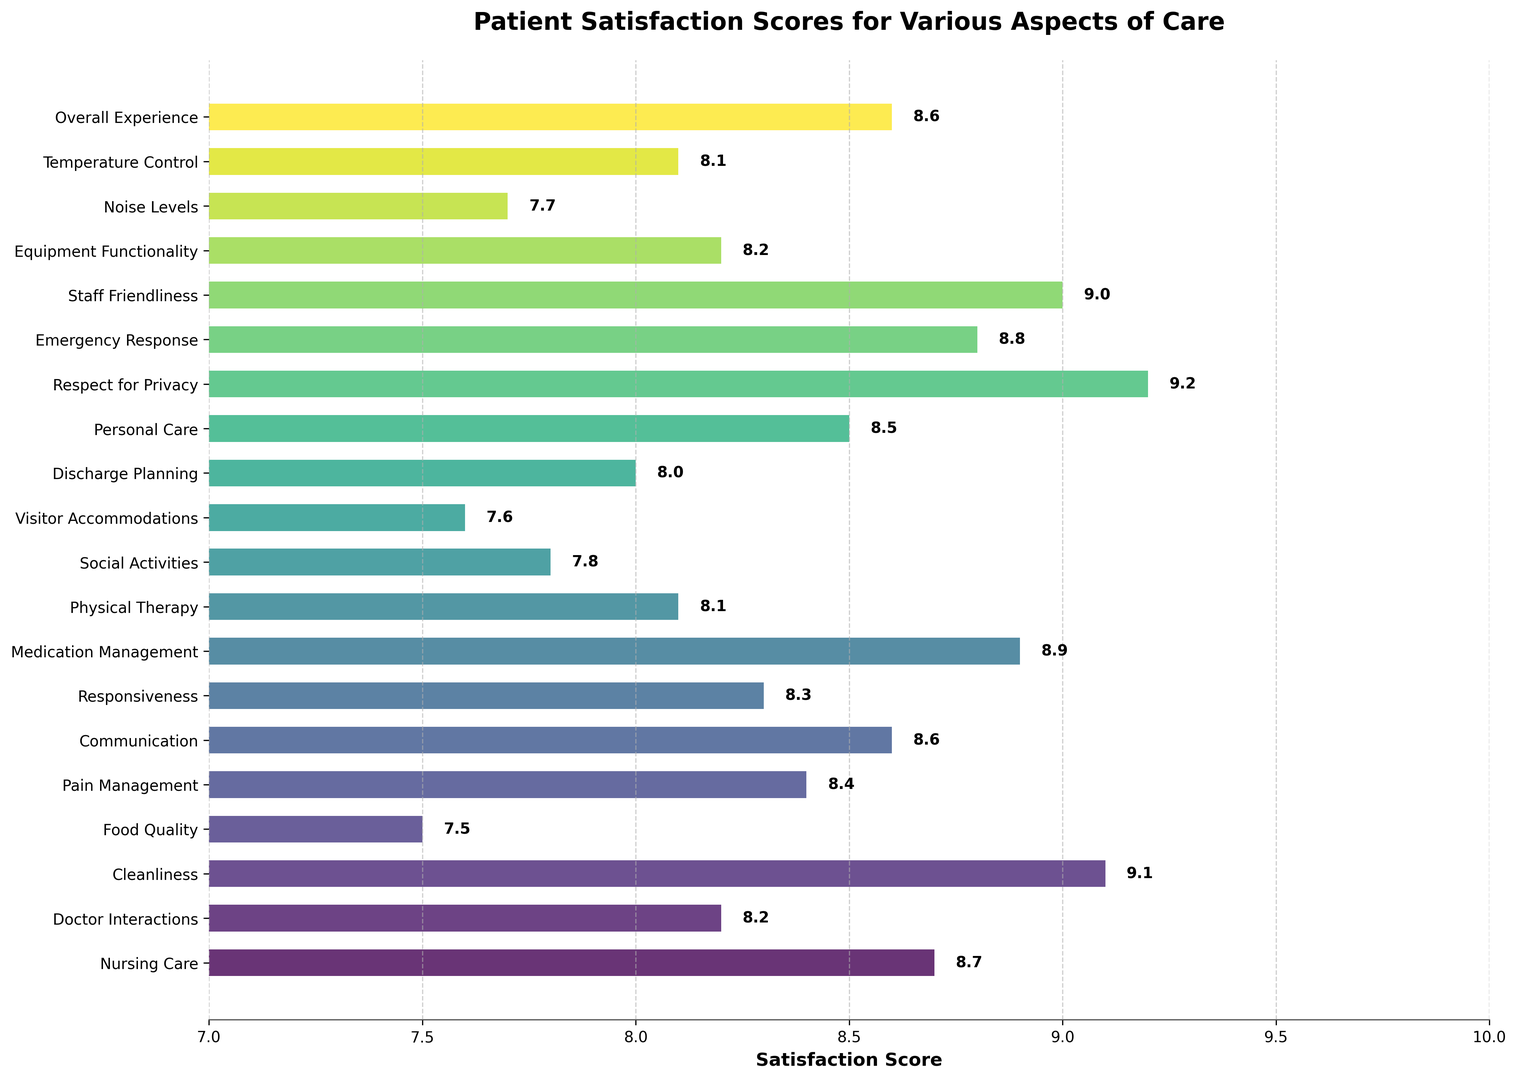What aspect of care has the highest satisfaction score? By looking at the figure, the bar representing "Respect for Privacy" is the longest, indicating the highest score of 9.2.
Answer: Respect for Privacy Which aspect of care has the lowest satisfaction score? The bar representing "Food Quality" is the shortest, indicating the lowest score of 7.5.
Answer: Food Quality How many aspects have a satisfaction score equal to or greater than 9? From the chart, the aspects "Respect for Privacy", "Cleanliness", and "Staff Friendliness" all show scores of 9.0 or higher. Verifying the count, there are exactly 3 such aspects.
Answer: 3 What is the difference in satisfaction scores between "Nursing Care" and "Food Quality"? The satisfaction score for "Nursing Care" is 8.7, while for "Food Quality" it is 7.5. Calculating the difference, 8.7 - 7.5 = 1.2.
Answer: 1.2 Which aspects of care have satisfaction scores between 8.5 and 9.0? By examining the chart, aspects like "Nursing Care", "Medication Management", "Communication", "Overall Experience", and "Staff Friendliness" have scores between 8.5 and 9.0.
Answer: Nursing Care, Medication Management, Communication, Overall Experience, Staff Friendliness Compare the satisfaction scores of "Emergency Response" and "Visitor Accommodations". Which one is higher and by how much? The score for "Emergency Response" is 8.8, and for "Visitor Accommodations" it is 7.6. The difference is 8.8 - 7.6 = 1.2, with "Emergency Response" having the higher score.
Answer: Emergency Response; 1.2 Which visual characteristic indicates the aspect with the highest score, and what is its value? The aspect with the highest satisfaction score is shown by the longest bar, which corresponds to "Respect for Privacy" with a score of 9.2.
Answer: Longest bar; 9.2 What's the average satisfaction score for "Doctor Interactions", "Physical Therapy", and "Discharge Planning"? The scores are 8.2, 8.1, and 8.0 respectively. Adding them up results in 24.3, and dividing by 3 gives an average score of 8.1.
Answer: 8.1 